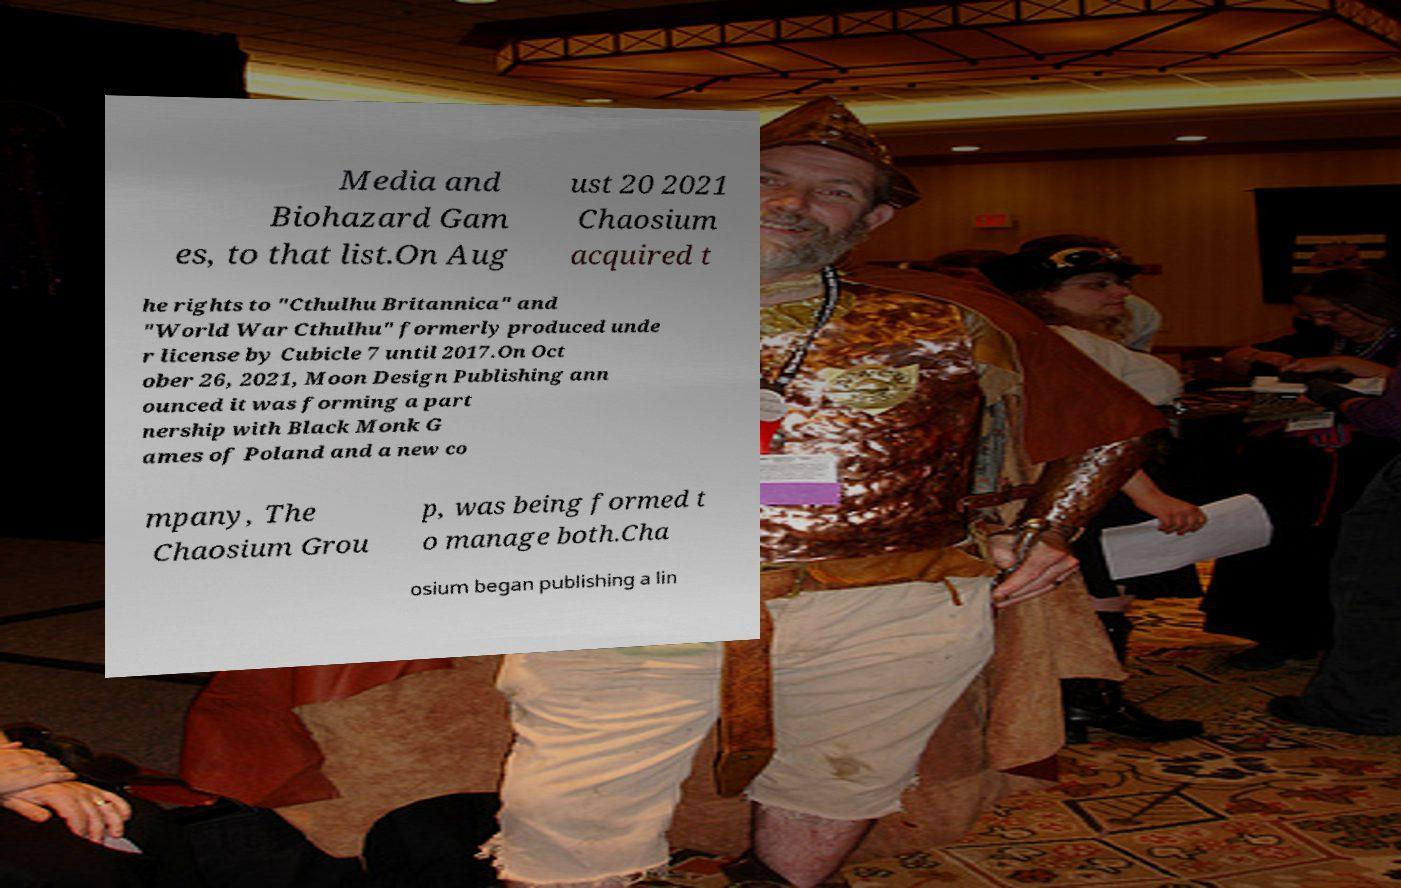For documentation purposes, I need the text within this image transcribed. Could you provide that? Media and Biohazard Gam es, to that list.On Aug ust 20 2021 Chaosium acquired t he rights to "Cthulhu Britannica" and "World War Cthulhu" formerly produced unde r license by Cubicle 7 until 2017.On Oct ober 26, 2021, Moon Design Publishing ann ounced it was forming a part nership with Black Monk G ames of Poland and a new co mpany, The Chaosium Grou p, was being formed t o manage both.Cha osium began publishing a lin 